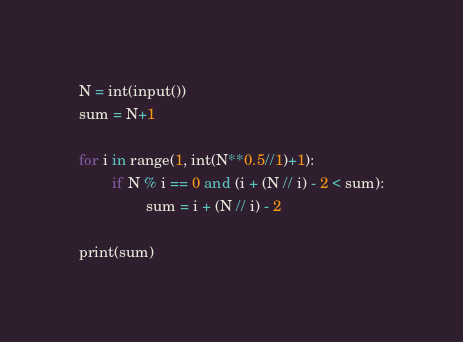Convert code to text. <code><loc_0><loc_0><loc_500><loc_500><_Python_>N = int(input())
sum = N+1

for i in range(1, int(N**0.5//1)+1):
        if N % i == 0 and (i + (N // i) - 2 < sum):
                sum = i + (N // i) - 2

print(sum)</code> 